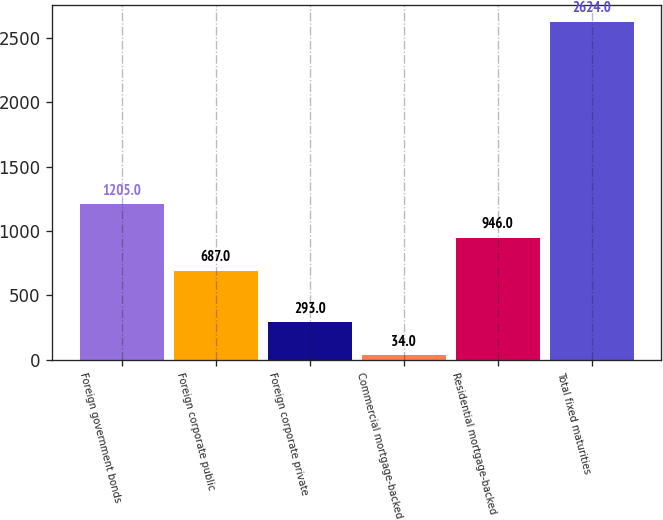Convert chart to OTSL. <chart><loc_0><loc_0><loc_500><loc_500><bar_chart><fcel>Foreign government bonds<fcel>Foreign corporate public<fcel>Foreign corporate private<fcel>Commercial mortgage-backed<fcel>Residential mortgage-backed<fcel>Total fixed maturities<nl><fcel>1205<fcel>687<fcel>293<fcel>34<fcel>946<fcel>2624<nl></chart> 